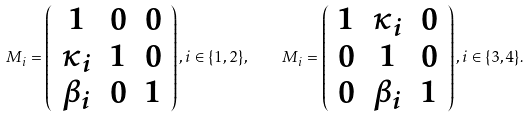Convert formula to latex. <formula><loc_0><loc_0><loc_500><loc_500>M _ { i } = \left ( \begin{array} { c c c } 1 & 0 & 0 \\ \kappa _ { i } & 1 & 0 \\ \beta _ { i } & 0 & 1 \end{array} \right ) , i \in \{ 1 , 2 \} , \quad M _ { i } = \left ( \begin{array} { c c c } 1 & \kappa _ { i } & 0 \\ 0 & 1 & 0 \\ 0 & \beta _ { i } & 1 \end{array} \right ) , i \in \{ 3 , 4 \} .</formula> 